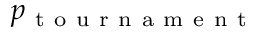Convert formula to latex. <formula><loc_0><loc_0><loc_500><loc_500>p _ { t o u r n a m e n t }</formula> 